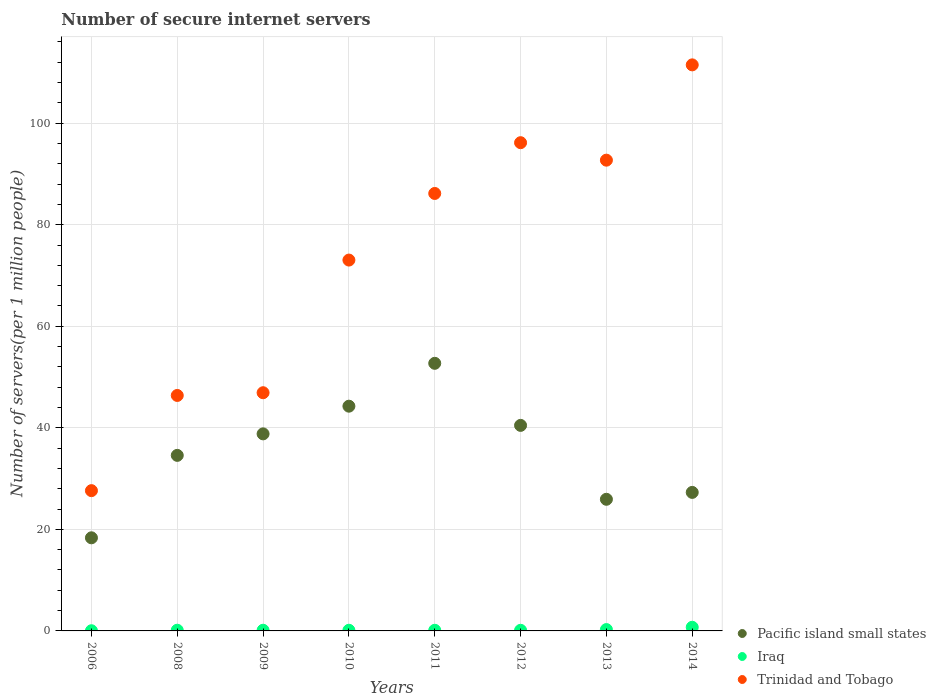Is the number of dotlines equal to the number of legend labels?
Ensure brevity in your answer.  Yes. What is the number of secure internet servers in Trinidad and Tobago in 2014?
Give a very brief answer. 111.48. Across all years, what is the maximum number of secure internet servers in Pacific island small states?
Offer a very short reply. 52.7. Across all years, what is the minimum number of secure internet servers in Trinidad and Tobago?
Your answer should be very brief. 27.63. What is the total number of secure internet servers in Pacific island small states in the graph?
Keep it short and to the point. 282.37. What is the difference between the number of secure internet servers in Iraq in 2006 and that in 2013?
Provide a succinct answer. -0.23. What is the difference between the number of secure internet servers in Trinidad and Tobago in 2011 and the number of secure internet servers in Pacific island small states in 2008?
Ensure brevity in your answer.  51.58. What is the average number of secure internet servers in Pacific island small states per year?
Make the answer very short. 35.3. In the year 2013, what is the difference between the number of secure internet servers in Iraq and number of secure internet servers in Trinidad and Tobago?
Offer a terse response. -92.45. In how many years, is the number of secure internet servers in Iraq greater than 108?
Your answer should be very brief. 0. What is the ratio of the number of secure internet servers in Pacific island small states in 2011 to that in 2013?
Offer a terse response. 2.03. Is the difference between the number of secure internet servers in Iraq in 2006 and 2014 greater than the difference between the number of secure internet servers in Trinidad and Tobago in 2006 and 2014?
Offer a terse response. Yes. What is the difference between the highest and the second highest number of secure internet servers in Pacific island small states?
Ensure brevity in your answer.  8.44. What is the difference between the highest and the lowest number of secure internet servers in Iraq?
Offer a very short reply. 0.68. Does the number of secure internet servers in Iraq monotonically increase over the years?
Ensure brevity in your answer.  No. Does the graph contain any zero values?
Your answer should be compact. No. Where does the legend appear in the graph?
Provide a short and direct response. Bottom right. How many legend labels are there?
Provide a short and direct response. 3. What is the title of the graph?
Ensure brevity in your answer.  Number of secure internet servers. Does "Middle income" appear as one of the legend labels in the graph?
Keep it short and to the point. No. What is the label or title of the Y-axis?
Offer a very short reply. Number of servers(per 1 million people). What is the Number of servers(per 1 million people) in Pacific island small states in 2006?
Ensure brevity in your answer.  18.34. What is the Number of servers(per 1 million people) in Iraq in 2006?
Provide a succinct answer. 0.04. What is the Number of servers(per 1 million people) in Trinidad and Tobago in 2006?
Your answer should be compact. 27.63. What is the Number of servers(per 1 million people) in Pacific island small states in 2008?
Ensure brevity in your answer.  34.57. What is the Number of servers(per 1 million people) in Iraq in 2008?
Keep it short and to the point. 0.14. What is the Number of servers(per 1 million people) in Trinidad and Tobago in 2008?
Offer a very short reply. 46.37. What is the Number of servers(per 1 million people) of Pacific island small states in 2009?
Provide a succinct answer. 38.81. What is the Number of servers(per 1 million people) in Iraq in 2009?
Give a very brief answer. 0.13. What is the Number of servers(per 1 million people) of Trinidad and Tobago in 2009?
Your answer should be very brief. 46.91. What is the Number of servers(per 1 million people) of Pacific island small states in 2010?
Offer a terse response. 44.26. What is the Number of servers(per 1 million people) of Iraq in 2010?
Make the answer very short. 0.13. What is the Number of servers(per 1 million people) in Trinidad and Tobago in 2010?
Your answer should be very brief. 73.04. What is the Number of servers(per 1 million people) in Pacific island small states in 2011?
Offer a very short reply. 52.7. What is the Number of servers(per 1 million people) of Iraq in 2011?
Provide a succinct answer. 0.13. What is the Number of servers(per 1 million people) in Trinidad and Tobago in 2011?
Offer a very short reply. 86.16. What is the Number of servers(per 1 million people) of Pacific island small states in 2012?
Offer a terse response. 40.48. What is the Number of servers(per 1 million people) in Iraq in 2012?
Offer a very short reply. 0.12. What is the Number of servers(per 1 million people) in Trinidad and Tobago in 2012?
Provide a succinct answer. 96.16. What is the Number of servers(per 1 million people) in Pacific island small states in 2013?
Ensure brevity in your answer.  25.92. What is the Number of servers(per 1 million people) of Iraq in 2013?
Ensure brevity in your answer.  0.27. What is the Number of servers(per 1 million people) of Trinidad and Tobago in 2013?
Give a very brief answer. 92.71. What is the Number of servers(per 1 million people) in Pacific island small states in 2014?
Make the answer very short. 27.28. What is the Number of servers(per 1 million people) in Iraq in 2014?
Ensure brevity in your answer.  0.72. What is the Number of servers(per 1 million people) in Trinidad and Tobago in 2014?
Your response must be concise. 111.48. Across all years, what is the maximum Number of servers(per 1 million people) in Pacific island small states?
Keep it short and to the point. 52.7. Across all years, what is the maximum Number of servers(per 1 million people) in Iraq?
Give a very brief answer. 0.72. Across all years, what is the maximum Number of servers(per 1 million people) of Trinidad and Tobago?
Your answer should be compact. 111.48. Across all years, what is the minimum Number of servers(per 1 million people) in Pacific island small states?
Provide a succinct answer. 18.34. Across all years, what is the minimum Number of servers(per 1 million people) in Iraq?
Offer a terse response. 0.04. Across all years, what is the minimum Number of servers(per 1 million people) in Trinidad and Tobago?
Make the answer very short. 27.63. What is the total Number of servers(per 1 million people) of Pacific island small states in the graph?
Your answer should be very brief. 282.37. What is the total Number of servers(per 1 million people) of Iraq in the graph?
Ensure brevity in your answer.  1.67. What is the total Number of servers(per 1 million people) of Trinidad and Tobago in the graph?
Offer a terse response. 580.46. What is the difference between the Number of servers(per 1 million people) in Pacific island small states in 2006 and that in 2008?
Offer a terse response. -16.23. What is the difference between the Number of servers(per 1 million people) of Iraq in 2006 and that in 2008?
Offer a very short reply. -0.1. What is the difference between the Number of servers(per 1 million people) of Trinidad and Tobago in 2006 and that in 2008?
Your response must be concise. -18.75. What is the difference between the Number of servers(per 1 million people) of Pacific island small states in 2006 and that in 2009?
Your answer should be compact. -20.47. What is the difference between the Number of servers(per 1 million people) of Iraq in 2006 and that in 2009?
Offer a terse response. -0.1. What is the difference between the Number of servers(per 1 million people) in Trinidad and Tobago in 2006 and that in 2009?
Offer a terse response. -19.29. What is the difference between the Number of servers(per 1 million people) in Pacific island small states in 2006 and that in 2010?
Your answer should be very brief. -25.92. What is the difference between the Number of servers(per 1 million people) in Iraq in 2006 and that in 2010?
Offer a terse response. -0.09. What is the difference between the Number of servers(per 1 million people) in Trinidad and Tobago in 2006 and that in 2010?
Your answer should be compact. -45.41. What is the difference between the Number of servers(per 1 million people) of Pacific island small states in 2006 and that in 2011?
Provide a short and direct response. -34.37. What is the difference between the Number of servers(per 1 million people) in Iraq in 2006 and that in 2011?
Your answer should be compact. -0.09. What is the difference between the Number of servers(per 1 million people) in Trinidad and Tobago in 2006 and that in 2011?
Offer a terse response. -58.53. What is the difference between the Number of servers(per 1 million people) of Pacific island small states in 2006 and that in 2012?
Make the answer very short. -22.14. What is the difference between the Number of servers(per 1 million people) in Iraq in 2006 and that in 2012?
Your answer should be compact. -0.09. What is the difference between the Number of servers(per 1 million people) of Trinidad and Tobago in 2006 and that in 2012?
Give a very brief answer. -68.53. What is the difference between the Number of servers(per 1 million people) in Pacific island small states in 2006 and that in 2013?
Offer a terse response. -7.59. What is the difference between the Number of servers(per 1 million people) in Iraq in 2006 and that in 2013?
Give a very brief answer. -0.23. What is the difference between the Number of servers(per 1 million people) in Trinidad and Tobago in 2006 and that in 2013?
Offer a very short reply. -65.09. What is the difference between the Number of servers(per 1 million people) of Pacific island small states in 2006 and that in 2014?
Your answer should be very brief. -8.94. What is the difference between the Number of servers(per 1 million people) in Iraq in 2006 and that in 2014?
Your answer should be compact. -0.68. What is the difference between the Number of servers(per 1 million people) of Trinidad and Tobago in 2006 and that in 2014?
Provide a short and direct response. -83.86. What is the difference between the Number of servers(per 1 million people) in Pacific island small states in 2008 and that in 2009?
Keep it short and to the point. -4.24. What is the difference between the Number of servers(per 1 million people) in Iraq in 2008 and that in 2009?
Keep it short and to the point. 0. What is the difference between the Number of servers(per 1 million people) in Trinidad and Tobago in 2008 and that in 2009?
Make the answer very short. -0.54. What is the difference between the Number of servers(per 1 million people) in Pacific island small states in 2008 and that in 2010?
Keep it short and to the point. -9.69. What is the difference between the Number of servers(per 1 million people) in Iraq in 2008 and that in 2010?
Your answer should be very brief. 0.01. What is the difference between the Number of servers(per 1 million people) in Trinidad and Tobago in 2008 and that in 2010?
Keep it short and to the point. -26.66. What is the difference between the Number of servers(per 1 million people) of Pacific island small states in 2008 and that in 2011?
Provide a short and direct response. -18.13. What is the difference between the Number of servers(per 1 million people) in Iraq in 2008 and that in 2011?
Your answer should be very brief. 0.01. What is the difference between the Number of servers(per 1 million people) in Trinidad and Tobago in 2008 and that in 2011?
Offer a very short reply. -39.78. What is the difference between the Number of servers(per 1 million people) of Pacific island small states in 2008 and that in 2012?
Give a very brief answer. -5.91. What is the difference between the Number of servers(per 1 million people) of Iraq in 2008 and that in 2012?
Provide a succinct answer. 0.02. What is the difference between the Number of servers(per 1 million people) in Trinidad and Tobago in 2008 and that in 2012?
Keep it short and to the point. -49.78. What is the difference between the Number of servers(per 1 million people) in Pacific island small states in 2008 and that in 2013?
Your response must be concise. 8.65. What is the difference between the Number of servers(per 1 million people) in Iraq in 2008 and that in 2013?
Ensure brevity in your answer.  -0.13. What is the difference between the Number of servers(per 1 million people) in Trinidad and Tobago in 2008 and that in 2013?
Your answer should be very brief. -46.34. What is the difference between the Number of servers(per 1 million people) of Pacific island small states in 2008 and that in 2014?
Your response must be concise. 7.29. What is the difference between the Number of servers(per 1 million people) in Iraq in 2008 and that in 2014?
Keep it short and to the point. -0.58. What is the difference between the Number of servers(per 1 million people) in Trinidad and Tobago in 2008 and that in 2014?
Offer a terse response. -65.11. What is the difference between the Number of servers(per 1 million people) in Pacific island small states in 2009 and that in 2010?
Offer a terse response. -5.45. What is the difference between the Number of servers(per 1 million people) in Iraq in 2009 and that in 2010?
Give a very brief answer. 0. What is the difference between the Number of servers(per 1 million people) of Trinidad and Tobago in 2009 and that in 2010?
Offer a very short reply. -26.12. What is the difference between the Number of servers(per 1 million people) in Pacific island small states in 2009 and that in 2011?
Keep it short and to the point. -13.89. What is the difference between the Number of servers(per 1 million people) in Iraq in 2009 and that in 2011?
Your response must be concise. 0.01. What is the difference between the Number of servers(per 1 million people) in Trinidad and Tobago in 2009 and that in 2011?
Ensure brevity in your answer.  -39.24. What is the difference between the Number of servers(per 1 million people) of Pacific island small states in 2009 and that in 2012?
Your response must be concise. -1.67. What is the difference between the Number of servers(per 1 million people) in Iraq in 2009 and that in 2012?
Keep it short and to the point. 0.01. What is the difference between the Number of servers(per 1 million people) in Trinidad and Tobago in 2009 and that in 2012?
Ensure brevity in your answer.  -49.24. What is the difference between the Number of servers(per 1 million people) of Pacific island small states in 2009 and that in 2013?
Your answer should be very brief. 12.88. What is the difference between the Number of servers(per 1 million people) of Iraq in 2009 and that in 2013?
Offer a very short reply. -0.13. What is the difference between the Number of servers(per 1 million people) of Trinidad and Tobago in 2009 and that in 2013?
Make the answer very short. -45.8. What is the difference between the Number of servers(per 1 million people) of Pacific island small states in 2009 and that in 2014?
Your response must be concise. 11.53. What is the difference between the Number of servers(per 1 million people) in Iraq in 2009 and that in 2014?
Your response must be concise. -0.58. What is the difference between the Number of servers(per 1 million people) in Trinidad and Tobago in 2009 and that in 2014?
Offer a very short reply. -64.57. What is the difference between the Number of servers(per 1 million people) of Pacific island small states in 2010 and that in 2011?
Offer a terse response. -8.44. What is the difference between the Number of servers(per 1 million people) in Iraq in 2010 and that in 2011?
Your response must be concise. 0. What is the difference between the Number of servers(per 1 million people) in Trinidad and Tobago in 2010 and that in 2011?
Offer a very short reply. -13.12. What is the difference between the Number of servers(per 1 million people) of Pacific island small states in 2010 and that in 2012?
Offer a very short reply. 3.78. What is the difference between the Number of servers(per 1 million people) in Iraq in 2010 and that in 2012?
Your answer should be very brief. 0.01. What is the difference between the Number of servers(per 1 million people) of Trinidad and Tobago in 2010 and that in 2012?
Provide a succinct answer. -23.12. What is the difference between the Number of servers(per 1 million people) in Pacific island small states in 2010 and that in 2013?
Ensure brevity in your answer.  18.34. What is the difference between the Number of servers(per 1 million people) in Iraq in 2010 and that in 2013?
Your answer should be compact. -0.14. What is the difference between the Number of servers(per 1 million people) in Trinidad and Tobago in 2010 and that in 2013?
Your answer should be compact. -19.68. What is the difference between the Number of servers(per 1 million people) in Pacific island small states in 2010 and that in 2014?
Provide a succinct answer. 16.98. What is the difference between the Number of servers(per 1 million people) of Iraq in 2010 and that in 2014?
Provide a succinct answer. -0.59. What is the difference between the Number of servers(per 1 million people) in Trinidad and Tobago in 2010 and that in 2014?
Offer a terse response. -38.44. What is the difference between the Number of servers(per 1 million people) of Pacific island small states in 2011 and that in 2012?
Offer a very short reply. 12.22. What is the difference between the Number of servers(per 1 million people) of Iraq in 2011 and that in 2012?
Your response must be concise. 0. What is the difference between the Number of servers(per 1 million people) of Trinidad and Tobago in 2011 and that in 2012?
Offer a terse response. -10. What is the difference between the Number of servers(per 1 million people) in Pacific island small states in 2011 and that in 2013?
Your answer should be compact. 26.78. What is the difference between the Number of servers(per 1 million people) of Iraq in 2011 and that in 2013?
Your answer should be compact. -0.14. What is the difference between the Number of servers(per 1 million people) of Trinidad and Tobago in 2011 and that in 2013?
Offer a terse response. -6.56. What is the difference between the Number of servers(per 1 million people) of Pacific island small states in 2011 and that in 2014?
Offer a very short reply. 25.42. What is the difference between the Number of servers(per 1 million people) in Iraq in 2011 and that in 2014?
Make the answer very short. -0.59. What is the difference between the Number of servers(per 1 million people) in Trinidad and Tobago in 2011 and that in 2014?
Make the answer very short. -25.33. What is the difference between the Number of servers(per 1 million people) of Pacific island small states in 2012 and that in 2013?
Provide a succinct answer. 14.56. What is the difference between the Number of servers(per 1 million people) in Iraq in 2012 and that in 2013?
Ensure brevity in your answer.  -0.14. What is the difference between the Number of servers(per 1 million people) of Trinidad and Tobago in 2012 and that in 2013?
Your answer should be very brief. 3.44. What is the difference between the Number of servers(per 1 million people) in Pacific island small states in 2012 and that in 2014?
Your response must be concise. 13.2. What is the difference between the Number of servers(per 1 million people) in Iraq in 2012 and that in 2014?
Ensure brevity in your answer.  -0.6. What is the difference between the Number of servers(per 1 million people) in Trinidad and Tobago in 2012 and that in 2014?
Make the answer very short. -15.33. What is the difference between the Number of servers(per 1 million people) of Pacific island small states in 2013 and that in 2014?
Provide a succinct answer. -1.36. What is the difference between the Number of servers(per 1 million people) of Iraq in 2013 and that in 2014?
Your response must be concise. -0.45. What is the difference between the Number of servers(per 1 million people) of Trinidad and Tobago in 2013 and that in 2014?
Provide a short and direct response. -18.77. What is the difference between the Number of servers(per 1 million people) in Pacific island small states in 2006 and the Number of servers(per 1 million people) in Iraq in 2008?
Provide a succinct answer. 18.2. What is the difference between the Number of servers(per 1 million people) in Pacific island small states in 2006 and the Number of servers(per 1 million people) in Trinidad and Tobago in 2008?
Provide a succinct answer. -28.04. What is the difference between the Number of servers(per 1 million people) of Iraq in 2006 and the Number of servers(per 1 million people) of Trinidad and Tobago in 2008?
Your answer should be compact. -46.34. What is the difference between the Number of servers(per 1 million people) in Pacific island small states in 2006 and the Number of servers(per 1 million people) in Iraq in 2009?
Make the answer very short. 18.21. What is the difference between the Number of servers(per 1 million people) in Pacific island small states in 2006 and the Number of servers(per 1 million people) in Trinidad and Tobago in 2009?
Keep it short and to the point. -28.57. What is the difference between the Number of servers(per 1 million people) of Iraq in 2006 and the Number of servers(per 1 million people) of Trinidad and Tobago in 2009?
Offer a very short reply. -46.88. What is the difference between the Number of servers(per 1 million people) in Pacific island small states in 2006 and the Number of servers(per 1 million people) in Iraq in 2010?
Offer a very short reply. 18.21. What is the difference between the Number of servers(per 1 million people) of Pacific island small states in 2006 and the Number of servers(per 1 million people) of Trinidad and Tobago in 2010?
Ensure brevity in your answer.  -54.7. What is the difference between the Number of servers(per 1 million people) of Iraq in 2006 and the Number of servers(per 1 million people) of Trinidad and Tobago in 2010?
Give a very brief answer. -73. What is the difference between the Number of servers(per 1 million people) of Pacific island small states in 2006 and the Number of servers(per 1 million people) of Iraq in 2011?
Your answer should be very brief. 18.21. What is the difference between the Number of servers(per 1 million people) of Pacific island small states in 2006 and the Number of servers(per 1 million people) of Trinidad and Tobago in 2011?
Give a very brief answer. -67.82. What is the difference between the Number of servers(per 1 million people) of Iraq in 2006 and the Number of servers(per 1 million people) of Trinidad and Tobago in 2011?
Your answer should be very brief. -86.12. What is the difference between the Number of servers(per 1 million people) of Pacific island small states in 2006 and the Number of servers(per 1 million people) of Iraq in 2012?
Ensure brevity in your answer.  18.22. What is the difference between the Number of servers(per 1 million people) of Pacific island small states in 2006 and the Number of servers(per 1 million people) of Trinidad and Tobago in 2012?
Offer a very short reply. -77.82. What is the difference between the Number of servers(per 1 million people) in Iraq in 2006 and the Number of servers(per 1 million people) in Trinidad and Tobago in 2012?
Make the answer very short. -96.12. What is the difference between the Number of servers(per 1 million people) in Pacific island small states in 2006 and the Number of servers(per 1 million people) in Iraq in 2013?
Provide a succinct answer. 18.07. What is the difference between the Number of servers(per 1 million people) in Pacific island small states in 2006 and the Number of servers(per 1 million people) in Trinidad and Tobago in 2013?
Your response must be concise. -74.37. What is the difference between the Number of servers(per 1 million people) in Iraq in 2006 and the Number of servers(per 1 million people) in Trinidad and Tobago in 2013?
Offer a terse response. -92.68. What is the difference between the Number of servers(per 1 million people) in Pacific island small states in 2006 and the Number of servers(per 1 million people) in Iraq in 2014?
Give a very brief answer. 17.62. What is the difference between the Number of servers(per 1 million people) of Pacific island small states in 2006 and the Number of servers(per 1 million people) of Trinidad and Tobago in 2014?
Your response must be concise. -93.14. What is the difference between the Number of servers(per 1 million people) of Iraq in 2006 and the Number of servers(per 1 million people) of Trinidad and Tobago in 2014?
Ensure brevity in your answer.  -111.45. What is the difference between the Number of servers(per 1 million people) of Pacific island small states in 2008 and the Number of servers(per 1 million people) of Iraq in 2009?
Your answer should be compact. 34.44. What is the difference between the Number of servers(per 1 million people) of Pacific island small states in 2008 and the Number of servers(per 1 million people) of Trinidad and Tobago in 2009?
Make the answer very short. -12.34. What is the difference between the Number of servers(per 1 million people) of Iraq in 2008 and the Number of servers(per 1 million people) of Trinidad and Tobago in 2009?
Make the answer very short. -46.77. What is the difference between the Number of servers(per 1 million people) of Pacific island small states in 2008 and the Number of servers(per 1 million people) of Iraq in 2010?
Make the answer very short. 34.44. What is the difference between the Number of servers(per 1 million people) of Pacific island small states in 2008 and the Number of servers(per 1 million people) of Trinidad and Tobago in 2010?
Your response must be concise. -38.46. What is the difference between the Number of servers(per 1 million people) of Iraq in 2008 and the Number of servers(per 1 million people) of Trinidad and Tobago in 2010?
Offer a terse response. -72.9. What is the difference between the Number of servers(per 1 million people) of Pacific island small states in 2008 and the Number of servers(per 1 million people) of Iraq in 2011?
Offer a very short reply. 34.45. What is the difference between the Number of servers(per 1 million people) in Pacific island small states in 2008 and the Number of servers(per 1 million people) in Trinidad and Tobago in 2011?
Ensure brevity in your answer.  -51.58. What is the difference between the Number of servers(per 1 million people) of Iraq in 2008 and the Number of servers(per 1 million people) of Trinidad and Tobago in 2011?
Keep it short and to the point. -86.02. What is the difference between the Number of servers(per 1 million people) in Pacific island small states in 2008 and the Number of servers(per 1 million people) in Iraq in 2012?
Provide a short and direct response. 34.45. What is the difference between the Number of servers(per 1 million people) of Pacific island small states in 2008 and the Number of servers(per 1 million people) of Trinidad and Tobago in 2012?
Make the answer very short. -61.58. What is the difference between the Number of servers(per 1 million people) of Iraq in 2008 and the Number of servers(per 1 million people) of Trinidad and Tobago in 2012?
Ensure brevity in your answer.  -96.02. What is the difference between the Number of servers(per 1 million people) of Pacific island small states in 2008 and the Number of servers(per 1 million people) of Iraq in 2013?
Make the answer very short. 34.31. What is the difference between the Number of servers(per 1 million people) of Pacific island small states in 2008 and the Number of servers(per 1 million people) of Trinidad and Tobago in 2013?
Your response must be concise. -58.14. What is the difference between the Number of servers(per 1 million people) of Iraq in 2008 and the Number of servers(per 1 million people) of Trinidad and Tobago in 2013?
Provide a short and direct response. -92.58. What is the difference between the Number of servers(per 1 million people) of Pacific island small states in 2008 and the Number of servers(per 1 million people) of Iraq in 2014?
Make the answer very short. 33.86. What is the difference between the Number of servers(per 1 million people) of Pacific island small states in 2008 and the Number of servers(per 1 million people) of Trinidad and Tobago in 2014?
Your answer should be very brief. -76.91. What is the difference between the Number of servers(per 1 million people) in Iraq in 2008 and the Number of servers(per 1 million people) in Trinidad and Tobago in 2014?
Ensure brevity in your answer.  -111.34. What is the difference between the Number of servers(per 1 million people) in Pacific island small states in 2009 and the Number of servers(per 1 million people) in Iraq in 2010?
Your answer should be compact. 38.68. What is the difference between the Number of servers(per 1 million people) of Pacific island small states in 2009 and the Number of servers(per 1 million people) of Trinidad and Tobago in 2010?
Your answer should be very brief. -34.23. What is the difference between the Number of servers(per 1 million people) of Iraq in 2009 and the Number of servers(per 1 million people) of Trinidad and Tobago in 2010?
Offer a very short reply. -72.9. What is the difference between the Number of servers(per 1 million people) in Pacific island small states in 2009 and the Number of servers(per 1 million people) in Iraq in 2011?
Keep it short and to the point. 38.68. What is the difference between the Number of servers(per 1 million people) in Pacific island small states in 2009 and the Number of servers(per 1 million people) in Trinidad and Tobago in 2011?
Offer a very short reply. -47.35. What is the difference between the Number of servers(per 1 million people) in Iraq in 2009 and the Number of servers(per 1 million people) in Trinidad and Tobago in 2011?
Your answer should be very brief. -86.02. What is the difference between the Number of servers(per 1 million people) in Pacific island small states in 2009 and the Number of servers(per 1 million people) in Iraq in 2012?
Make the answer very short. 38.69. What is the difference between the Number of servers(per 1 million people) of Pacific island small states in 2009 and the Number of servers(per 1 million people) of Trinidad and Tobago in 2012?
Your response must be concise. -57.35. What is the difference between the Number of servers(per 1 million people) of Iraq in 2009 and the Number of servers(per 1 million people) of Trinidad and Tobago in 2012?
Make the answer very short. -96.02. What is the difference between the Number of servers(per 1 million people) of Pacific island small states in 2009 and the Number of servers(per 1 million people) of Iraq in 2013?
Provide a succinct answer. 38.54. What is the difference between the Number of servers(per 1 million people) of Pacific island small states in 2009 and the Number of servers(per 1 million people) of Trinidad and Tobago in 2013?
Your response must be concise. -53.9. What is the difference between the Number of servers(per 1 million people) of Iraq in 2009 and the Number of servers(per 1 million people) of Trinidad and Tobago in 2013?
Ensure brevity in your answer.  -92.58. What is the difference between the Number of servers(per 1 million people) in Pacific island small states in 2009 and the Number of servers(per 1 million people) in Iraq in 2014?
Keep it short and to the point. 38.09. What is the difference between the Number of servers(per 1 million people) in Pacific island small states in 2009 and the Number of servers(per 1 million people) in Trinidad and Tobago in 2014?
Provide a succinct answer. -72.67. What is the difference between the Number of servers(per 1 million people) of Iraq in 2009 and the Number of servers(per 1 million people) of Trinidad and Tobago in 2014?
Keep it short and to the point. -111.35. What is the difference between the Number of servers(per 1 million people) of Pacific island small states in 2010 and the Number of servers(per 1 million people) of Iraq in 2011?
Keep it short and to the point. 44.13. What is the difference between the Number of servers(per 1 million people) in Pacific island small states in 2010 and the Number of servers(per 1 million people) in Trinidad and Tobago in 2011?
Provide a short and direct response. -41.9. What is the difference between the Number of servers(per 1 million people) of Iraq in 2010 and the Number of servers(per 1 million people) of Trinidad and Tobago in 2011?
Give a very brief answer. -86.03. What is the difference between the Number of servers(per 1 million people) of Pacific island small states in 2010 and the Number of servers(per 1 million people) of Iraq in 2012?
Your answer should be compact. 44.14. What is the difference between the Number of servers(per 1 million people) of Pacific island small states in 2010 and the Number of servers(per 1 million people) of Trinidad and Tobago in 2012?
Make the answer very short. -51.89. What is the difference between the Number of servers(per 1 million people) in Iraq in 2010 and the Number of servers(per 1 million people) in Trinidad and Tobago in 2012?
Offer a terse response. -96.03. What is the difference between the Number of servers(per 1 million people) of Pacific island small states in 2010 and the Number of servers(per 1 million people) of Iraq in 2013?
Keep it short and to the point. 43.99. What is the difference between the Number of servers(per 1 million people) in Pacific island small states in 2010 and the Number of servers(per 1 million people) in Trinidad and Tobago in 2013?
Offer a terse response. -48.45. What is the difference between the Number of servers(per 1 million people) in Iraq in 2010 and the Number of servers(per 1 million people) in Trinidad and Tobago in 2013?
Ensure brevity in your answer.  -92.58. What is the difference between the Number of servers(per 1 million people) in Pacific island small states in 2010 and the Number of servers(per 1 million people) in Iraq in 2014?
Provide a succinct answer. 43.54. What is the difference between the Number of servers(per 1 million people) of Pacific island small states in 2010 and the Number of servers(per 1 million people) of Trinidad and Tobago in 2014?
Your answer should be compact. -67.22. What is the difference between the Number of servers(per 1 million people) of Iraq in 2010 and the Number of servers(per 1 million people) of Trinidad and Tobago in 2014?
Your response must be concise. -111.35. What is the difference between the Number of servers(per 1 million people) of Pacific island small states in 2011 and the Number of servers(per 1 million people) of Iraq in 2012?
Offer a terse response. 52.58. What is the difference between the Number of servers(per 1 million people) of Pacific island small states in 2011 and the Number of servers(per 1 million people) of Trinidad and Tobago in 2012?
Your response must be concise. -43.45. What is the difference between the Number of servers(per 1 million people) of Iraq in 2011 and the Number of servers(per 1 million people) of Trinidad and Tobago in 2012?
Provide a succinct answer. -96.03. What is the difference between the Number of servers(per 1 million people) in Pacific island small states in 2011 and the Number of servers(per 1 million people) in Iraq in 2013?
Provide a short and direct response. 52.44. What is the difference between the Number of servers(per 1 million people) in Pacific island small states in 2011 and the Number of servers(per 1 million people) in Trinidad and Tobago in 2013?
Provide a succinct answer. -40.01. What is the difference between the Number of servers(per 1 million people) in Iraq in 2011 and the Number of servers(per 1 million people) in Trinidad and Tobago in 2013?
Provide a succinct answer. -92.59. What is the difference between the Number of servers(per 1 million people) of Pacific island small states in 2011 and the Number of servers(per 1 million people) of Iraq in 2014?
Provide a succinct answer. 51.99. What is the difference between the Number of servers(per 1 million people) in Pacific island small states in 2011 and the Number of servers(per 1 million people) in Trinidad and Tobago in 2014?
Give a very brief answer. -58.78. What is the difference between the Number of servers(per 1 million people) in Iraq in 2011 and the Number of servers(per 1 million people) in Trinidad and Tobago in 2014?
Offer a terse response. -111.36. What is the difference between the Number of servers(per 1 million people) of Pacific island small states in 2012 and the Number of servers(per 1 million people) of Iraq in 2013?
Your response must be concise. 40.21. What is the difference between the Number of servers(per 1 million people) of Pacific island small states in 2012 and the Number of servers(per 1 million people) of Trinidad and Tobago in 2013?
Offer a terse response. -52.23. What is the difference between the Number of servers(per 1 million people) in Iraq in 2012 and the Number of servers(per 1 million people) in Trinidad and Tobago in 2013?
Your answer should be very brief. -92.59. What is the difference between the Number of servers(per 1 million people) of Pacific island small states in 2012 and the Number of servers(per 1 million people) of Iraq in 2014?
Provide a succinct answer. 39.76. What is the difference between the Number of servers(per 1 million people) in Pacific island small states in 2012 and the Number of servers(per 1 million people) in Trinidad and Tobago in 2014?
Offer a very short reply. -71. What is the difference between the Number of servers(per 1 million people) in Iraq in 2012 and the Number of servers(per 1 million people) in Trinidad and Tobago in 2014?
Offer a terse response. -111.36. What is the difference between the Number of servers(per 1 million people) of Pacific island small states in 2013 and the Number of servers(per 1 million people) of Iraq in 2014?
Provide a succinct answer. 25.21. What is the difference between the Number of servers(per 1 million people) of Pacific island small states in 2013 and the Number of servers(per 1 million people) of Trinidad and Tobago in 2014?
Your answer should be compact. -85.56. What is the difference between the Number of servers(per 1 million people) in Iraq in 2013 and the Number of servers(per 1 million people) in Trinidad and Tobago in 2014?
Keep it short and to the point. -111.22. What is the average Number of servers(per 1 million people) in Pacific island small states per year?
Offer a terse response. 35.3. What is the average Number of servers(per 1 million people) in Iraq per year?
Give a very brief answer. 0.21. What is the average Number of servers(per 1 million people) of Trinidad and Tobago per year?
Provide a short and direct response. 72.56. In the year 2006, what is the difference between the Number of servers(per 1 million people) in Pacific island small states and Number of servers(per 1 million people) in Iraq?
Your answer should be very brief. 18.3. In the year 2006, what is the difference between the Number of servers(per 1 million people) in Pacific island small states and Number of servers(per 1 million people) in Trinidad and Tobago?
Offer a very short reply. -9.29. In the year 2006, what is the difference between the Number of servers(per 1 million people) of Iraq and Number of servers(per 1 million people) of Trinidad and Tobago?
Give a very brief answer. -27.59. In the year 2008, what is the difference between the Number of servers(per 1 million people) in Pacific island small states and Number of servers(per 1 million people) in Iraq?
Your response must be concise. 34.44. In the year 2008, what is the difference between the Number of servers(per 1 million people) of Pacific island small states and Number of servers(per 1 million people) of Trinidad and Tobago?
Ensure brevity in your answer.  -11.8. In the year 2008, what is the difference between the Number of servers(per 1 million people) in Iraq and Number of servers(per 1 million people) in Trinidad and Tobago?
Your answer should be very brief. -46.24. In the year 2009, what is the difference between the Number of servers(per 1 million people) of Pacific island small states and Number of servers(per 1 million people) of Iraq?
Provide a short and direct response. 38.68. In the year 2009, what is the difference between the Number of servers(per 1 million people) in Pacific island small states and Number of servers(per 1 million people) in Trinidad and Tobago?
Provide a short and direct response. -8.1. In the year 2009, what is the difference between the Number of servers(per 1 million people) of Iraq and Number of servers(per 1 million people) of Trinidad and Tobago?
Offer a terse response. -46.78. In the year 2010, what is the difference between the Number of servers(per 1 million people) of Pacific island small states and Number of servers(per 1 million people) of Iraq?
Make the answer very short. 44.13. In the year 2010, what is the difference between the Number of servers(per 1 million people) in Pacific island small states and Number of servers(per 1 million people) in Trinidad and Tobago?
Offer a very short reply. -28.78. In the year 2010, what is the difference between the Number of servers(per 1 million people) of Iraq and Number of servers(per 1 million people) of Trinidad and Tobago?
Make the answer very short. -72.91. In the year 2011, what is the difference between the Number of servers(per 1 million people) in Pacific island small states and Number of servers(per 1 million people) in Iraq?
Provide a short and direct response. 52.58. In the year 2011, what is the difference between the Number of servers(per 1 million people) of Pacific island small states and Number of servers(per 1 million people) of Trinidad and Tobago?
Give a very brief answer. -33.45. In the year 2011, what is the difference between the Number of servers(per 1 million people) of Iraq and Number of servers(per 1 million people) of Trinidad and Tobago?
Your response must be concise. -86.03. In the year 2012, what is the difference between the Number of servers(per 1 million people) in Pacific island small states and Number of servers(per 1 million people) in Iraq?
Your answer should be compact. 40.36. In the year 2012, what is the difference between the Number of servers(per 1 million people) in Pacific island small states and Number of servers(per 1 million people) in Trinidad and Tobago?
Keep it short and to the point. -55.68. In the year 2012, what is the difference between the Number of servers(per 1 million people) in Iraq and Number of servers(per 1 million people) in Trinidad and Tobago?
Give a very brief answer. -96.03. In the year 2013, what is the difference between the Number of servers(per 1 million people) in Pacific island small states and Number of servers(per 1 million people) in Iraq?
Make the answer very short. 25.66. In the year 2013, what is the difference between the Number of servers(per 1 million people) of Pacific island small states and Number of servers(per 1 million people) of Trinidad and Tobago?
Your answer should be very brief. -66.79. In the year 2013, what is the difference between the Number of servers(per 1 million people) in Iraq and Number of servers(per 1 million people) in Trinidad and Tobago?
Provide a short and direct response. -92.45. In the year 2014, what is the difference between the Number of servers(per 1 million people) of Pacific island small states and Number of servers(per 1 million people) of Iraq?
Provide a succinct answer. 26.56. In the year 2014, what is the difference between the Number of servers(per 1 million people) in Pacific island small states and Number of servers(per 1 million people) in Trinidad and Tobago?
Provide a short and direct response. -84.2. In the year 2014, what is the difference between the Number of servers(per 1 million people) of Iraq and Number of servers(per 1 million people) of Trinidad and Tobago?
Offer a very short reply. -110.76. What is the ratio of the Number of servers(per 1 million people) in Pacific island small states in 2006 to that in 2008?
Make the answer very short. 0.53. What is the ratio of the Number of servers(per 1 million people) in Iraq in 2006 to that in 2008?
Give a very brief answer. 0.26. What is the ratio of the Number of servers(per 1 million people) in Trinidad and Tobago in 2006 to that in 2008?
Keep it short and to the point. 0.6. What is the ratio of the Number of servers(per 1 million people) in Pacific island small states in 2006 to that in 2009?
Your response must be concise. 0.47. What is the ratio of the Number of servers(per 1 million people) in Iraq in 2006 to that in 2009?
Give a very brief answer. 0.27. What is the ratio of the Number of servers(per 1 million people) in Trinidad and Tobago in 2006 to that in 2009?
Ensure brevity in your answer.  0.59. What is the ratio of the Number of servers(per 1 million people) of Pacific island small states in 2006 to that in 2010?
Make the answer very short. 0.41. What is the ratio of the Number of servers(per 1 million people) in Iraq in 2006 to that in 2010?
Make the answer very short. 0.28. What is the ratio of the Number of servers(per 1 million people) of Trinidad and Tobago in 2006 to that in 2010?
Offer a very short reply. 0.38. What is the ratio of the Number of servers(per 1 million people) in Pacific island small states in 2006 to that in 2011?
Offer a terse response. 0.35. What is the ratio of the Number of servers(per 1 million people) in Iraq in 2006 to that in 2011?
Offer a terse response. 0.29. What is the ratio of the Number of servers(per 1 million people) in Trinidad and Tobago in 2006 to that in 2011?
Your answer should be very brief. 0.32. What is the ratio of the Number of servers(per 1 million people) of Pacific island small states in 2006 to that in 2012?
Your answer should be compact. 0.45. What is the ratio of the Number of servers(per 1 million people) in Iraq in 2006 to that in 2012?
Your answer should be very brief. 0.3. What is the ratio of the Number of servers(per 1 million people) of Trinidad and Tobago in 2006 to that in 2012?
Give a very brief answer. 0.29. What is the ratio of the Number of servers(per 1 million people) in Pacific island small states in 2006 to that in 2013?
Ensure brevity in your answer.  0.71. What is the ratio of the Number of servers(per 1 million people) of Iraq in 2006 to that in 2013?
Provide a short and direct response. 0.14. What is the ratio of the Number of servers(per 1 million people) of Trinidad and Tobago in 2006 to that in 2013?
Your answer should be compact. 0.3. What is the ratio of the Number of servers(per 1 million people) in Pacific island small states in 2006 to that in 2014?
Offer a terse response. 0.67. What is the ratio of the Number of servers(per 1 million people) in Iraq in 2006 to that in 2014?
Your answer should be compact. 0.05. What is the ratio of the Number of servers(per 1 million people) of Trinidad and Tobago in 2006 to that in 2014?
Provide a short and direct response. 0.25. What is the ratio of the Number of servers(per 1 million people) in Pacific island small states in 2008 to that in 2009?
Provide a succinct answer. 0.89. What is the ratio of the Number of servers(per 1 million people) in Iraq in 2008 to that in 2009?
Offer a terse response. 1.03. What is the ratio of the Number of servers(per 1 million people) of Pacific island small states in 2008 to that in 2010?
Your answer should be very brief. 0.78. What is the ratio of the Number of servers(per 1 million people) of Iraq in 2008 to that in 2010?
Make the answer very short. 1.06. What is the ratio of the Number of servers(per 1 million people) in Trinidad and Tobago in 2008 to that in 2010?
Make the answer very short. 0.63. What is the ratio of the Number of servers(per 1 million people) of Pacific island small states in 2008 to that in 2011?
Ensure brevity in your answer.  0.66. What is the ratio of the Number of servers(per 1 million people) of Iraq in 2008 to that in 2011?
Make the answer very short. 1.09. What is the ratio of the Number of servers(per 1 million people) of Trinidad and Tobago in 2008 to that in 2011?
Your response must be concise. 0.54. What is the ratio of the Number of servers(per 1 million people) in Pacific island small states in 2008 to that in 2012?
Your answer should be very brief. 0.85. What is the ratio of the Number of servers(per 1 million people) of Iraq in 2008 to that in 2012?
Make the answer very short. 1.12. What is the ratio of the Number of servers(per 1 million people) in Trinidad and Tobago in 2008 to that in 2012?
Provide a succinct answer. 0.48. What is the ratio of the Number of servers(per 1 million people) of Pacific island small states in 2008 to that in 2013?
Ensure brevity in your answer.  1.33. What is the ratio of the Number of servers(per 1 million people) of Iraq in 2008 to that in 2013?
Ensure brevity in your answer.  0.51. What is the ratio of the Number of servers(per 1 million people) of Trinidad and Tobago in 2008 to that in 2013?
Ensure brevity in your answer.  0.5. What is the ratio of the Number of servers(per 1 million people) in Pacific island small states in 2008 to that in 2014?
Your answer should be compact. 1.27. What is the ratio of the Number of servers(per 1 million people) in Iraq in 2008 to that in 2014?
Provide a short and direct response. 0.19. What is the ratio of the Number of servers(per 1 million people) in Trinidad and Tobago in 2008 to that in 2014?
Your answer should be very brief. 0.42. What is the ratio of the Number of servers(per 1 million people) of Pacific island small states in 2009 to that in 2010?
Keep it short and to the point. 0.88. What is the ratio of the Number of servers(per 1 million people) of Iraq in 2009 to that in 2010?
Provide a short and direct response. 1.03. What is the ratio of the Number of servers(per 1 million people) of Trinidad and Tobago in 2009 to that in 2010?
Make the answer very short. 0.64. What is the ratio of the Number of servers(per 1 million people) in Pacific island small states in 2009 to that in 2011?
Provide a succinct answer. 0.74. What is the ratio of the Number of servers(per 1 million people) of Iraq in 2009 to that in 2011?
Provide a succinct answer. 1.06. What is the ratio of the Number of servers(per 1 million people) of Trinidad and Tobago in 2009 to that in 2011?
Your answer should be compact. 0.54. What is the ratio of the Number of servers(per 1 million people) of Pacific island small states in 2009 to that in 2012?
Keep it short and to the point. 0.96. What is the ratio of the Number of servers(per 1 million people) in Iraq in 2009 to that in 2012?
Your answer should be very brief. 1.09. What is the ratio of the Number of servers(per 1 million people) in Trinidad and Tobago in 2009 to that in 2012?
Offer a very short reply. 0.49. What is the ratio of the Number of servers(per 1 million people) of Pacific island small states in 2009 to that in 2013?
Your answer should be compact. 1.5. What is the ratio of the Number of servers(per 1 million people) of Iraq in 2009 to that in 2013?
Provide a succinct answer. 0.5. What is the ratio of the Number of servers(per 1 million people) in Trinidad and Tobago in 2009 to that in 2013?
Your answer should be very brief. 0.51. What is the ratio of the Number of servers(per 1 million people) in Pacific island small states in 2009 to that in 2014?
Provide a short and direct response. 1.42. What is the ratio of the Number of servers(per 1 million people) in Iraq in 2009 to that in 2014?
Offer a terse response. 0.19. What is the ratio of the Number of servers(per 1 million people) in Trinidad and Tobago in 2009 to that in 2014?
Offer a terse response. 0.42. What is the ratio of the Number of servers(per 1 million people) in Pacific island small states in 2010 to that in 2011?
Ensure brevity in your answer.  0.84. What is the ratio of the Number of servers(per 1 million people) in Iraq in 2010 to that in 2011?
Offer a very short reply. 1.03. What is the ratio of the Number of servers(per 1 million people) of Trinidad and Tobago in 2010 to that in 2011?
Ensure brevity in your answer.  0.85. What is the ratio of the Number of servers(per 1 million people) in Pacific island small states in 2010 to that in 2012?
Provide a succinct answer. 1.09. What is the ratio of the Number of servers(per 1 million people) in Iraq in 2010 to that in 2012?
Provide a short and direct response. 1.06. What is the ratio of the Number of servers(per 1 million people) in Trinidad and Tobago in 2010 to that in 2012?
Provide a succinct answer. 0.76. What is the ratio of the Number of servers(per 1 million people) in Pacific island small states in 2010 to that in 2013?
Make the answer very short. 1.71. What is the ratio of the Number of servers(per 1 million people) of Iraq in 2010 to that in 2013?
Offer a terse response. 0.49. What is the ratio of the Number of servers(per 1 million people) of Trinidad and Tobago in 2010 to that in 2013?
Provide a succinct answer. 0.79. What is the ratio of the Number of servers(per 1 million people) in Pacific island small states in 2010 to that in 2014?
Your answer should be compact. 1.62. What is the ratio of the Number of servers(per 1 million people) of Iraq in 2010 to that in 2014?
Your answer should be very brief. 0.18. What is the ratio of the Number of servers(per 1 million people) in Trinidad and Tobago in 2010 to that in 2014?
Your answer should be compact. 0.66. What is the ratio of the Number of servers(per 1 million people) of Pacific island small states in 2011 to that in 2012?
Ensure brevity in your answer.  1.3. What is the ratio of the Number of servers(per 1 million people) in Iraq in 2011 to that in 2012?
Provide a succinct answer. 1.03. What is the ratio of the Number of servers(per 1 million people) of Trinidad and Tobago in 2011 to that in 2012?
Ensure brevity in your answer.  0.9. What is the ratio of the Number of servers(per 1 million people) in Pacific island small states in 2011 to that in 2013?
Give a very brief answer. 2.03. What is the ratio of the Number of servers(per 1 million people) in Iraq in 2011 to that in 2013?
Provide a succinct answer. 0.47. What is the ratio of the Number of servers(per 1 million people) in Trinidad and Tobago in 2011 to that in 2013?
Offer a very short reply. 0.93. What is the ratio of the Number of servers(per 1 million people) of Pacific island small states in 2011 to that in 2014?
Your response must be concise. 1.93. What is the ratio of the Number of servers(per 1 million people) of Iraq in 2011 to that in 2014?
Your answer should be compact. 0.18. What is the ratio of the Number of servers(per 1 million people) of Trinidad and Tobago in 2011 to that in 2014?
Make the answer very short. 0.77. What is the ratio of the Number of servers(per 1 million people) in Pacific island small states in 2012 to that in 2013?
Give a very brief answer. 1.56. What is the ratio of the Number of servers(per 1 million people) in Iraq in 2012 to that in 2013?
Give a very brief answer. 0.46. What is the ratio of the Number of servers(per 1 million people) of Trinidad and Tobago in 2012 to that in 2013?
Your answer should be very brief. 1.04. What is the ratio of the Number of servers(per 1 million people) of Pacific island small states in 2012 to that in 2014?
Keep it short and to the point. 1.48. What is the ratio of the Number of servers(per 1 million people) in Iraq in 2012 to that in 2014?
Give a very brief answer. 0.17. What is the ratio of the Number of servers(per 1 million people) of Trinidad and Tobago in 2012 to that in 2014?
Provide a succinct answer. 0.86. What is the ratio of the Number of servers(per 1 million people) of Pacific island small states in 2013 to that in 2014?
Keep it short and to the point. 0.95. What is the ratio of the Number of servers(per 1 million people) of Iraq in 2013 to that in 2014?
Your answer should be very brief. 0.37. What is the ratio of the Number of servers(per 1 million people) in Trinidad and Tobago in 2013 to that in 2014?
Your answer should be very brief. 0.83. What is the difference between the highest and the second highest Number of servers(per 1 million people) of Pacific island small states?
Offer a terse response. 8.44. What is the difference between the highest and the second highest Number of servers(per 1 million people) in Iraq?
Provide a succinct answer. 0.45. What is the difference between the highest and the second highest Number of servers(per 1 million people) in Trinidad and Tobago?
Give a very brief answer. 15.33. What is the difference between the highest and the lowest Number of servers(per 1 million people) in Pacific island small states?
Your response must be concise. 34.37. What is the difference between the highest and the lowest Number of servers(per 1 million people) of Iraq?
Your answer should be compact. 0.68. What is the difference between the highest and the lowest Number of servers(per 1 million people) of Trinidad and Tobago?
Provide a succinct answer. 83.86. 